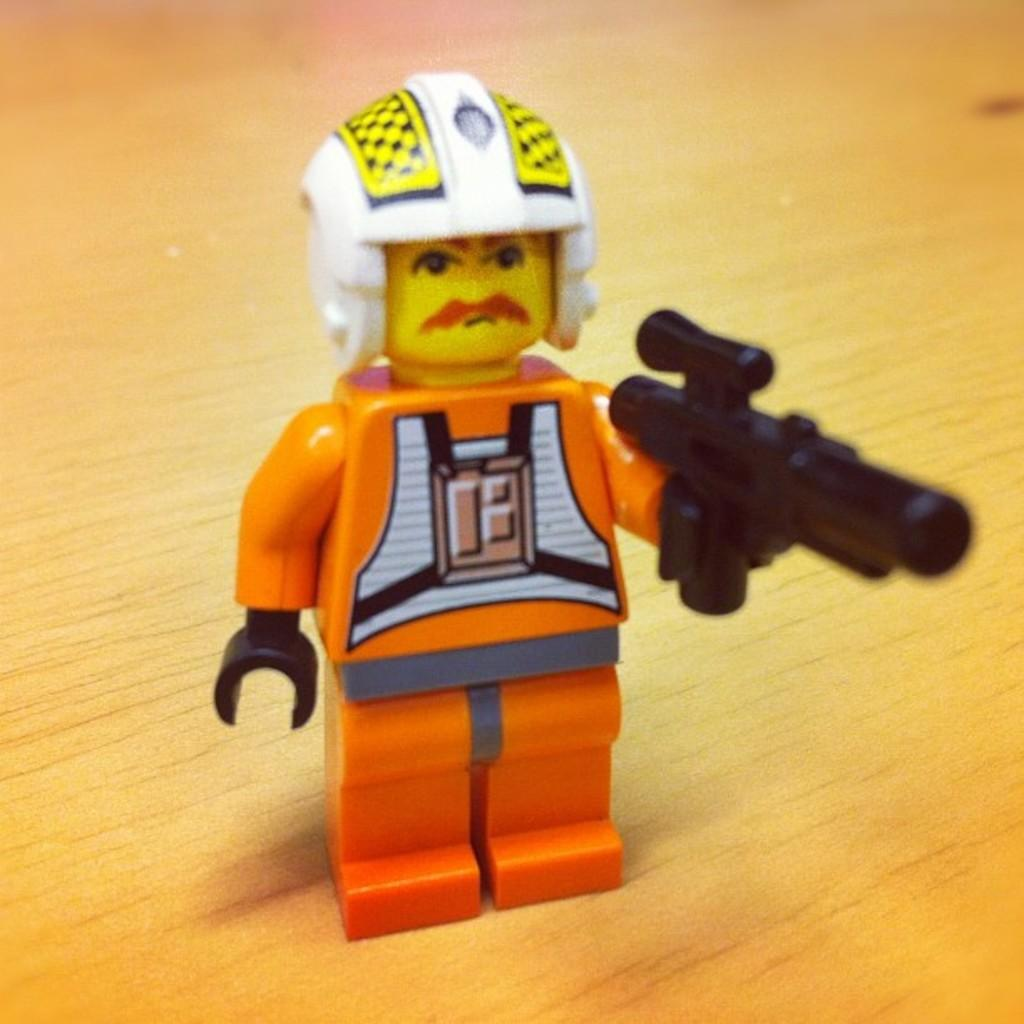What type of toy is in the image? There is a Lego toy in the image. What does the Lego toy resemble? The Lego toy resembles a person. What is the Lego toy holding? The Lego toy is holding an object. Where is the object placed? The object is placed on a table. What type of squirrel can be seen playing in the park in the image? There is no squirrel or park present in the image; it features a Lego toy resembling a person holding an object. What sound does the Lego toy make in the image? Lego toys do not make sounds, so there is no sound to describe in the image. 